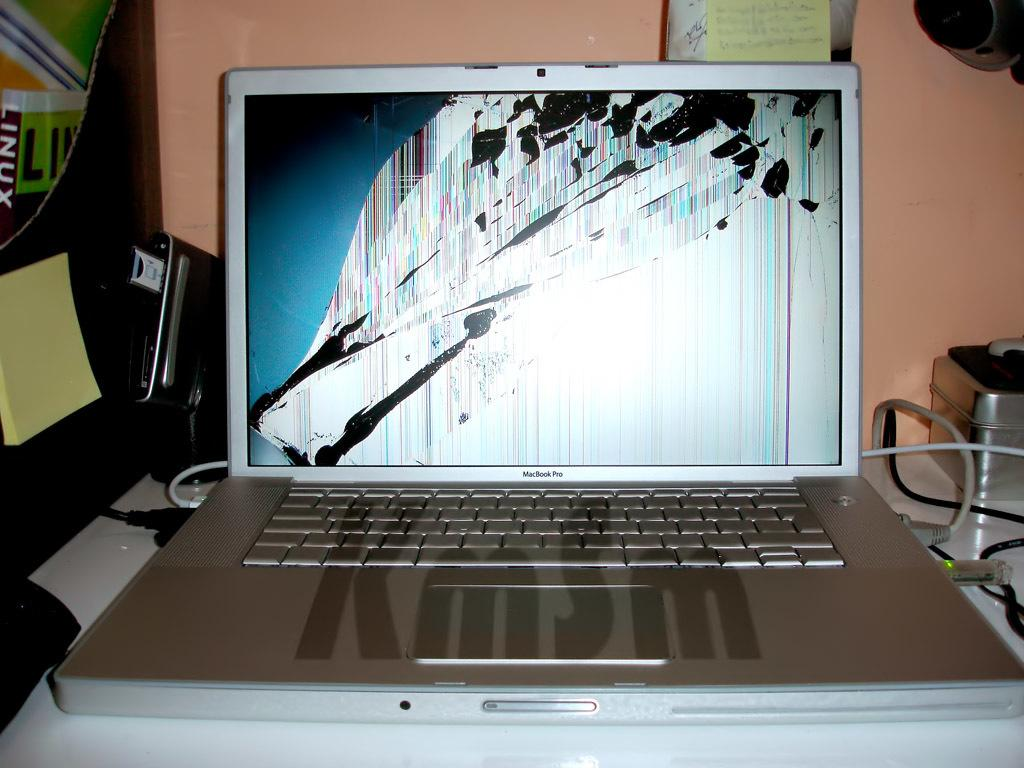<image>
Share a concise interpretation of the image provided. A picture of a laptop with a damaged screen and a watermark that says "KmSm." 